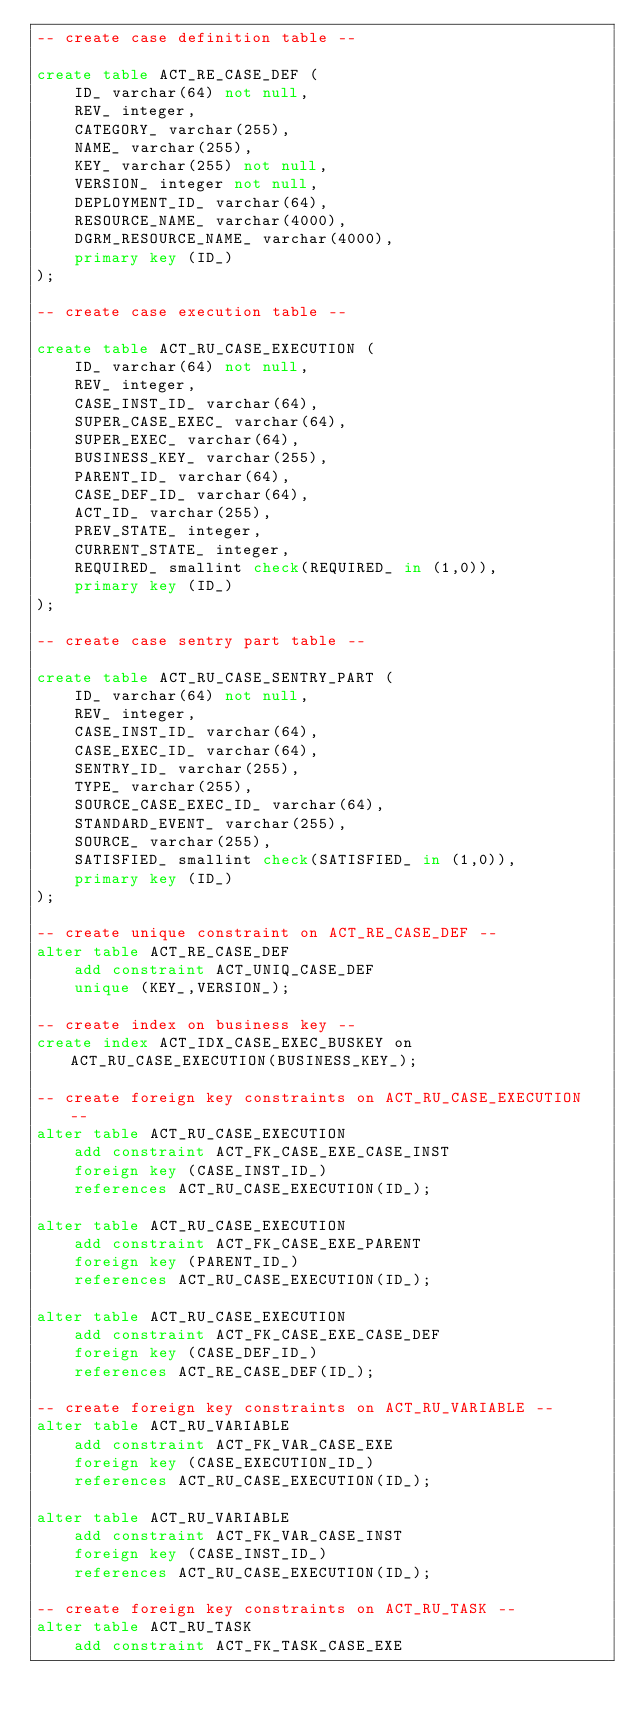Convert code to text. <code><loc_0><loc_0><loc_500><loc_500><_SQL_>-- create case definition table --

create table ACT_RE_CASE_DEF (
    ID_ varchar(64) not null,
    REV_ integer,
    CATEGORY_ varchar(255),
    NAME_ varchar(255),
    KEY_ varchar(255) not null,
    VERSION_ integer not null,
    DEPLOYMENT_ID_ varchar(64),
    RESOURCE_NAME_ varchar(4000),
    DGRM_RESOURCE_NAME_ varchar(4000),
    primary key (ID_)
);

-- create case execution table --

create table ACT_RU_CASE_EXECUTION (
    ID_ varchar(64) not null,
    REV_ integer,
    CASE_INST_ID_ varchar(64),
    SUPER_CASE_EXEC_ varchar(64),
    SUPER_EXEC_ varchar(64),
    BUSINESS_KEY_ varchar(255),
    PARENT_ID_ varchar(64),
    CASE_DEF_ID_ varchar(64),
    ACT_ID_ varchar(255),
    PREV_STATE_ integer,
    CURRENT_STATE_ integer,
    REQUIRED_ smallint check(REQUIRED_ in (1,0)),
    primary key (ID_)
);

-- create case sentry part table --

create table ACT_RU_CASE_SENTRY_PART (
    ID_ varchar(64) not null,
    REV_ integer,
    CASE_INST_ID_ varchar(64),
    CASE_EXEC_ID_ varchar(64),
    SENTRY_ID_ varchar(255),
    TYPE_ varchar(255),
    SOURCE_CASE_EXEC_ID_ varchar(64),
    STANDARD_EVENT_ varchar(255),
    SOURCE_ varchar(255),
    SATISFIED_ smallint check(SATISFIED_ in (1,0)),
    primary key (ID_)
);

-- create unique constraint on ACT_RE_CASE_DEF --
alter table ACT_RE_CASE_DEF
    add constraint ACT_UNIQ_CASE_DEF
    unique (KEY_,VERSION_);

-- create index on business key --
create index ACT_IDX_CASE_EXEC_BUSKEY on ACT_RU_CASE_EXECUTION(BUSINESS_KEY_);

-- create foreign key constraints on ACT_RU_CASE_EXECUTION --
alter table ACT_RU_CASE_EXECUTION
    add constraint ACT_FK_CASE_EXE_CASE_INST
    foreign key (CASE_INST_ID_)
    references ACT_RU_CASE_EXECUTION(ID_);

alter table ACT_RU_CASE_EXECUTION
    add constraint ACT_FK_CASE_EXE_PARENT
    foreign key (PARENT_ID_)
    references ACT_RU_CASE_EXECUTION(ID_);

alter table ACT_RU_CASE_EXECUTION
    add constraint ACT_FK_CASE_EXE_CASE_DEF
    foreign key (CASE_DEF_ID_)
    references ACT_RE_CASE_DEF(ID_);

-- create foreign key constraints on ACT_RU_VARIABLE --
alter table ACT_RU_VARIABLE
    add constraint ACT_FK_VAR_CASE_EXE
    foreign key (CASE_EXECUTION_ID_)
    references ACT_RU_CASE_EXECUTION(ID_);

alter table ACT_RU_VARIABLE
    add constraint ACT_FK_VAR_CASE_INST
    foreign key (CASE_INST_ID_)
    references ACT_RU_CASE_EXECUTION(ID_);

-- create foreign key constraints on ACT_RU_TASK --
alter table ACT_RU_TASK
    add constraint ACT_FK_TASK_CASE_EXE</code> 